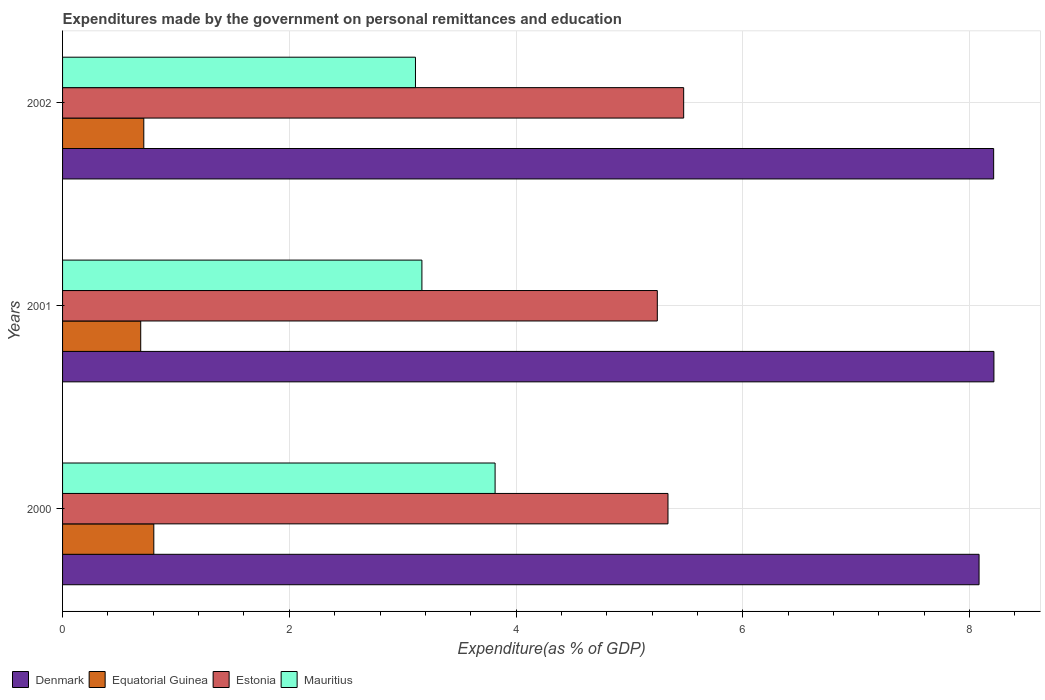How many different coloured bars are there?
Make the answer very short. 4. How many groups of bars are there?
Provide a succinct answer. 3. Are the number of bars per tick equal to the number of legend labels?
Give a very brief answer. Yes. How many bars are there on the 1st tick from the top?
Keep it short and to the point. 4. How many bars are there on the 1st tick from the bottom?
Give a very brief answer. 4. What is the expenditures made by the government on personal remittances and education in Estonia in 2001?
Your answer should be compact. 5.25. Across all years, what is the maximum expenditures made by the government on personal remittances and education in Denmark?
Offer a very short reply. 8.22. Across all years, what is the minimum expenditures made by the government on personal remittances and education in Mauritius?
Ensure brevity in your answer.  3.11. What is the total expenditures made by the government on personal remittances and education in Mauritius in the graph?
Offer a terse response. 10.1. What is the difference between the expenditures made by the government on personal remittances and education in Mauritius in 2001 and that in 2002?
Your answer should be very brief. 0.06. What is the difference between the expenditures made by the government on personal remittances and education in Denmark in 2000 and the expenditures made by the government on personal remittances and education in Equatorial Guinea in 2002?
Your answer should be very brief. 7.37. What is the average expenditures made by the government on personal remittances and education in Estonia per year?
Offer a very short reply. 5.36. In the year 2000, what is the difference between the expenditures made by the government on personal remittances and education in Denmark and expenditures made by the government on personal remittances and education in Estonia?
Ensure brevity in your answer.  2.74. In how many years, is the expenditures made by the government on personal remittances and education in Estonia greater than 2 %?
Offer a terse response. 3. What is the ratio of the expenditures made by the government on personal remittances and education in Mauritius in 2001 to that in 2002?
Your response must be concise. 1.02. Is the difference between the expenditures made by the government on personal remittances and education in Denmark in 2000 and 2002 greater than the difference between the expenditures made by the government on personal remittances and education in Estonia in 2000 and 2002?
Keep it short and to the point. Yes. What is the difference between the highest and the second highest expenditures made by the government on personal remittances and education in Equatorial Guinea?
Provide a short and direct response. 0.09. What is the difference between the highest and the lowest expenditures made by the government on personal remittances and education in Denmark?
Ensure brevity in your answer.  0.13. Is the sum of the expenditures made by the government on personal remittances and education in Equatorial Guinea in 2001 and 2002 greater than the maximum expenditures made by the government on personal remittances and education in Denmark across all years?
Your answer should be compact. No. Is it the case that in every year, the sum of the expenditures made by the government on personal remittances and education in Mauritius and expenditures made by the government on personal remittances and education in Denmark is greater than the sum of expenditures made by the government on personal remittances and education in Estonia and expenditures made by the government on personal remittances and education in Equatorial Guinea?
Ensure brevity in your answer.  Yes. What does the 2nd bar from the top in 2000 represents?
Give a very brief answer. Estonia. What does the 3rd bar from the bottom in 2000 represents?
Keep it short and to the point. Estonia. Is it the case that in every year, the sum of the expenditures made by the government on personal remittances and education in Estonia and expenditures made by the government on personal remittances and education in Denmark is greater than the expenditures made by the government on personal remittances and education in Mauritius?
Your response must be concise. Yes. How many bars are there?
Your answer should be compact. 12. What is the difference between two consecutive major ticks on the X-axis?
Provide a short and direct response. 2. Are the values on the major ticks of X-axis written in scientific E-notation?
Offer a very short reply. No. Where does the legend appear in the graph?
Provide a short and direct response. Bottom left. How many legend labels are there?
Your answer should be very brief. 4. How are the legend labels stacked?
Provide a succinct answer. Horizontal. What is the title of the graph?
Ensure brevity in your answer.  Expenditures made by the government on personal remittances and education. What is the label or title of the X-axis?
Offer a terse response. Expenditure(as % of GDP). What is the Expenditure(as % of GDP) in Denmark in 2000?
Keep it short and to the point. 8.08. What is the Expenditure(as % of GDP) of Equatorial Guinea in 2000?
Make the answer very short. 0.8. What is the Expenditure(as % of GDP) of Estonia in 2000?
Offer a terse response. 5.34. What is the Expenditure(as % of GDP) in Mauritius in 2000?
Your answer should be very brief. 3.82. What is the Expenditure(as % of GDP) in Denmark in 2001?
Give a very brief answer. 8.22. What is the Expenditure(as % of GDP) of Equatorial Guinea in 2001?
Offer a terse response. 0.69. What is the Expenditure(as % of GDP) of Estonia in 2001?
Offer a terse response. 5.25. What is the Expenditure(as % of GDP) of Mauritius in 2001?
Provide a short and direct response. 3.17. What is the Expenditure(as % of GDP) of Denmark in 2002?
Provide a succinct answer. 8.21. What is the Expenditure(as % of GDP) of Equatorial Guinea in 2002?
Offer a terse response. 0.72. What is the Expenditure(as % of GDP) in Estonia in 2002?
Provide a succinct answer. 5.48. What is the Expenditure(as % of GDP) in Mauritius in 2002?
Make the answer very short. 3.11. Across all years, what is the maximum Expenditure(as % of GDP) in Denmark?
Provide a short and direct response. 8.22. Across all years, what is the maximum Expenditure(as % of GDP) in Equatorial Guinea?
Offer a terse response. 0.8. Across all years, what is the maximum Expenditure(as % of GDP) of Estonia?
Your answer should be very brief. 5.48. Across all years, what is the maximum Expenditure(as % of GDP) of Mauritius?
Make the answer very short. 3.82. Across all years, what is the minimum Expenditure(as % of GDP) of Denmark?
Offer a terse response. 8.08. Across all years, what is the minimum Expenditure(as % of GDP) of Equatorial Guinea?
Your answer should be compact. 0.69. Across all years, what is the minimum Expenditure(as % of GDP) of Estonia?
Make the answer very short. 5.25. Across all years, what is the minimum Expenditure(as % of GDP) in Mauritius?
Make the answer very short. 3.11. What is the total Expenditure(as % of GDP) of Denmark in the graph?
Provide a short and direct response. 24.51. What is the total Expenditure(as % of GDP) of Equatorial Guinea in the graph?
Keep it short and to the point. 2.21. What is the total Expenditure(as % of GDP) in Estonia in the graph?
Provide a short and direct response. 16.07. What is the total Expenditure(as % of GDP) of Mauritius in the graph?
Offer a terse response. 10.1. What is the difference between the Expenditure(as % of GDP) of Denmark in 2000 and that in 2001?
Offer a very short reply. -0.13. What is the difference between the Expenditure(as % of GDP) of Equatorial Guinea in 2000 and that in 2001?
Ensure brevity in your answer.  0.12. What is the difference between the Expenditure(as % of GDP) in Estonia in 2000 and that in 2001?
Your answer should be compact. 0.09. What is the difference between the Expenditure(as % of GDP) in Mauritius in 2000 and that in 2001?
Provide a succinct answer. 0.65. What is the difference between the Expenditure(as % of GDP) of Denmark in 2000 and that in 2002?
Make the answer very short. -0.13. What is the difference between the Expenditure(as % of GDP) of Equatorial Guinea in 2000 and that in 2002?
Provide a short and direct response. 0.09. What is the difference between the Expenditure(as % of GDP) of Estonia in 2000 and that in 2002?
Keep it short and to the point. -0.14. What is the difference between the Expenditure(as % of GDP) in Mauritius in 2000 and that in 2002?
Keep it short and to the point. 0.7. What is the difference between the Expenditure(as % of GDP) in Denmark in 2001 and that in 2002?
Your answer should be compact. 0. What is the difference between the Expenditure(as % of GDP) in Equatorial Guinea in 2001 and that in 2002?
Offer a very short reply. -0.03. What is the difference between the Expenditure(as % of GDP) in Estonia in 2001 and that in 2002?
Your response must be concise. -0.23. What is the difference between the Expenditure(as % of GDP) of Mauritius in 2001 and that in 2002?
Ensure brevity in your answer.  0.06. What is the difference between the Expenditure(as % of GDP) of Denmark in 2000 and the Expenditure(as % of GDP) of Equatorial Guinea in 2001?
Offer a terse response. 7.39. What is the difference between the Expenditure(as % of GDP) in Denmark in 2000 and the Expenditure(as % of GDP) in Estonia in 2001?
Keep it short and to the point. 2.84. What is the difference between the Expenditure(as % of GDP) of Denmark in 2000 and the Expenditure(as % of GDP) of Mauritius in 2001?
Your answer should be compact. 4.91. What is the difference between the Expenditure(as % of GDP) of Equatorial Guinea in 2000 and the Expenditure(as % of GDP) of Estonia in 2001?
Offer a very short reply. -4.44. What is the difference between the Expenditure(as % of GDP) of Equatorial Guinea in 2000 and the Expenditure(as % of GDP) of Mauritius in 2001?
Offer a terse response. -2.36. What is the difference between the Expenditure(as % of GDP) of Estonia in 2000 and the Expenditure(as % of GDP) of Mauritius in 2001?
Keep it short and to the point. 2.17. What is the difference between the Expenditure(as % of GDP) in Denmark in 2000 and the Expenditure(as % of GDP) in Equatorial Guinea in 2002?
Keep it short and to the point. 7.37. What is the difference between the Expenditure(as % of GDP) of Denmark in 2000 and the Expenditure(as % of GDP) of Estonia in 2002?
Give a very brief answer. 2.61. What is the difference between the Expenditure(as % of GDP) of Denmark in 2000 and the Expenditure(as % of GDP) of Mauritius in 2002?
Provide a short and direct response. 4.97. What is the difference between the Expenditure(as % of GDP) of Equatorial Guinea in 2000 and the Expenditure(as % of GDP) of Estonia in 2002?
Keep it short and to the point. -4.67. What is the difference between the Expenditure(as % of GDP) of Equatorial Guinea in 2000 and the Expenditure(as % of GDP) of Mauritius in 2002?
Offer a terse response. -2.31. What is the difference between the Expenditure(as % of GDP) in Estonia in 2000 and the Expenditure(as % of GDP) in Mauritius in 2002?
Provide a short and direct response. 2.23. What is the difference between the Expenditure(as % of GDP) in Denmark in 2001 and the Expenditure(as % of GDP) in Equatorial Guinea in 2002?
Offer a very short reply. 7.5. What is the difference between the Expenditure(as % of GDP) of Denmark in 2001 and the Expenditure(as % of GDP) of Estonia in 2002?
Give a very brief answer. 2.74. What is the difference between the Expenditure(as % of GDP) of Denmark in 2001 and the Expenditure(as % of GDP) of Mauritius in 2002?
Provide a succinct answer. 5.1. What is the difference between the Expenditure(as % of GDP) of Equatorial Guinea in 2001 and the Expenditure(as % of GDP) of Estonia in 2002?
Your response must be concise. -4.79. What is the difference between the Expenditure(as % of GDP) of Equatorial Guinea in 2001 and the Expenditure(as % of GDP) of Mauritius in 2002?
Offer a very short reply. -2.42. What is the difference between the Expenditure(as % of GDP) in Estonia in 2001 and the Expenditure(as % of GDP) in Mauritius in 2002?
Offer a terse response. 2.13. What is the average Expenditure(as % of GDP) in Denmark per year?
Give a very brief answer. 8.17. What is the average Expenditure(as % of GDP) of Equatorial Guinea per year?
Make the answer very short. 0.74. What is the average Expenditure(as % of GDP) of Estonia per year?
Offer a terse response. 5.36. What is the average Expenditure(as % of GDP) in Mauritius per year?
Your response must be concise. 3.37. In the year 2000, what is the difference between the Expenditure(as % of GDP) in Denmark and Expenditure(as % of GDP) in Equatorial Guinea?
Give a very brief answer. 7.28. In the year 2000, what is the difference between the Expenditure(as % of GDP) in Denmark and Expenditure(as % of GDP) in Estonia?
Offer a terse response. 2.74. In the year 2000, what is the difference between the Expenditure(as % of GDP) of Denmark and Expenditure(as % of GDP) of Mauritius?
Keep it short and to the point. 4.27. In the year 2000, what is the difference between the Expenditure(as % of GDP) of Equatorial Guinea and Expenditure(as % of GDP) of Estonia?
Keep it short and to the point. -4.54. In the year 2000, what is the difference between the Expenditure(as % of GDP) of Equatorial Guinea and Expenditure(as % of GDP) of Mauritius?
Give a very brief answer. -3.01. In the year 2000, what is the difference between the Expenditure(as % of GDP) of Estonia and Expenditure(as % of GDP) of Mauritius?
Give a very brief answer. 1.53. In the year 2001, what is the difference between the Expenditure(as % of GDP) of Denmark and Expenditure(as % of GDP) of Equatorial Guinea?
Provide a succinct answer. 7.53. In the year 2001, what is the difference between the Expenditure(as % of GDP) of Denmark and Expenditure(as % of GDP) of Estonia?
Provide a short and direct response. 2.97. In the year 2001, what is the difference between the Expenditure(as % of GDP) in Denmark and Expenditure(as % of GDP) in Mauritius?
Ensure brevity in your answer.  5.05. In the year 2001, what is the difference between the Expenditure(as % of GDP) of Equatorial Guinea and Expenditure(as % of GDP) of Estonia?
Give a very brief answer. -4.56. In the year 2001, what is the difference between the Expenditure(as % of GDP) in Equatorial Guinea and Expenditure(as % of GDP) in Mauritius?
Your answer should be compact. -2.48. In the year 2001, what is the difference between the Expenditure(as % of GDP) in Estonia and Expenditure(as % of GDP) in Mauritius?
Provide a succinct answer. 2.08. In the year 2002, what is the difference between the Expenditure(as % of GDP) in Denmark and Expenditure(as % of GDP) in Equatorial Guinea?
Your response must be concise. 7.5. In the year 2002, what is the difference between the Expenditure(as % of GDP) of Denmark and Expenditure(as % of GDP) of Estonia?
Your response must be concise. 2.73. In the year 2002, what is the difference between the Expenditure(as % of GDP) of Denmark and Expenditure(as % of GDP) of Mauritius?
Offer a very short reply. 5.1. In the year 2002, what is the difference between the Expenditure(as % of GDP) of Equatorial Guinea and Expenditure(as % of GDP) of Estonia?
Make the answer very short. -4.76. In the year 2002, what is the difference between the Expenditure(as % of GDP) of Equatorial Guinea and Expenditure(as % of GDP) of Mauritius?
Keep it short and to the point. -2.4. In the year 2002, what is the difference between the Expenditure(as % of GDP) of Estonia and Expenditure(as % of GDP) of Mauritius?
Give a very brief answer. 2.37. What is the ratio of the Expenditure(as % of GDP) in Equatorial Guinea in 2000 to that in 2001?
Your answer should be very brief. 1.17. What is the ratio of the Expenditure(as % of GDP) in Mauritius in 2000 to that in 2001?
Provide a succinct answer. 1.2. What is the ratio of the Expenditure(as % of GDP) in Denmark in 2000 to that in 2002?
Offer a very short reply. 0.98. What is the ratio of the Expenditure(as % of GDP) in Equatorial Guinea in 2000 to that in 2002?
Offer a very short reply. 1.12. What is the ratio of the Expenditure(as % of GDP) of Estonia in 2000 to that in 2002?
Provide a succinct answer. 0.97. What is the ratio of the Expenditure(as % of GDP) of Mauritius in 2000 to that in 2002?
Provide a short and direct response. 1.23. What is the ratio of the Expenditure(as % of GDP) in Denmark in 2001 to that in 2002?
Offer a very short reply. 1. What is the ratio of the Expenditure(as % of GDP) in Equatorial Guinea in 2001 to that in 2002?
Your response must be concise. 0.96. What is the ratio of the Expenditure(as % of GDP) in Estonia in 2001 to that in 2002?
Give a very brief answer. 0.96. What is the ratio of the Expenditure(as % of GDP) of Mauritius in 2001 to that in 2002?
Your answer should be compact. 1.02. What is the difference between the highest and the second highest Expenditure(as % of GDP) in Denmark?
Offer a very short reply. 0. What is the difference between the highest and the second highest Expenditure(as % of GDP) of Equatorial Guinea?
Your answer should be compact. 0.09. What is the difference between the highest and the second highest Expenditure(as % of GDP) of Estonia?
Give a very brief answer. 0.14. What is the difference between the highest and the second highest Expenditure(as % of GDP) of Mauritius?
Keep it short and to the point. 0.65. What is the difference between the highest and the lowest Expenditure(as % of GDP) in Denmark?
Ensure brevity in your answer.  0.13. What is the difference between the highest and the lowest Expenditure(as % of GDP) of Equatorial Guinea?
Your answer should be very brief. 0.12. What is the difference between the highest and the lowest Expenditure(as % of GDP) of Estonia?
Your answer should be very brief. 0.23. What is the difference between the highest and the lowest Expenditure(as % of GDP) in Mauritius?
Make the answer very short. 0.7. 